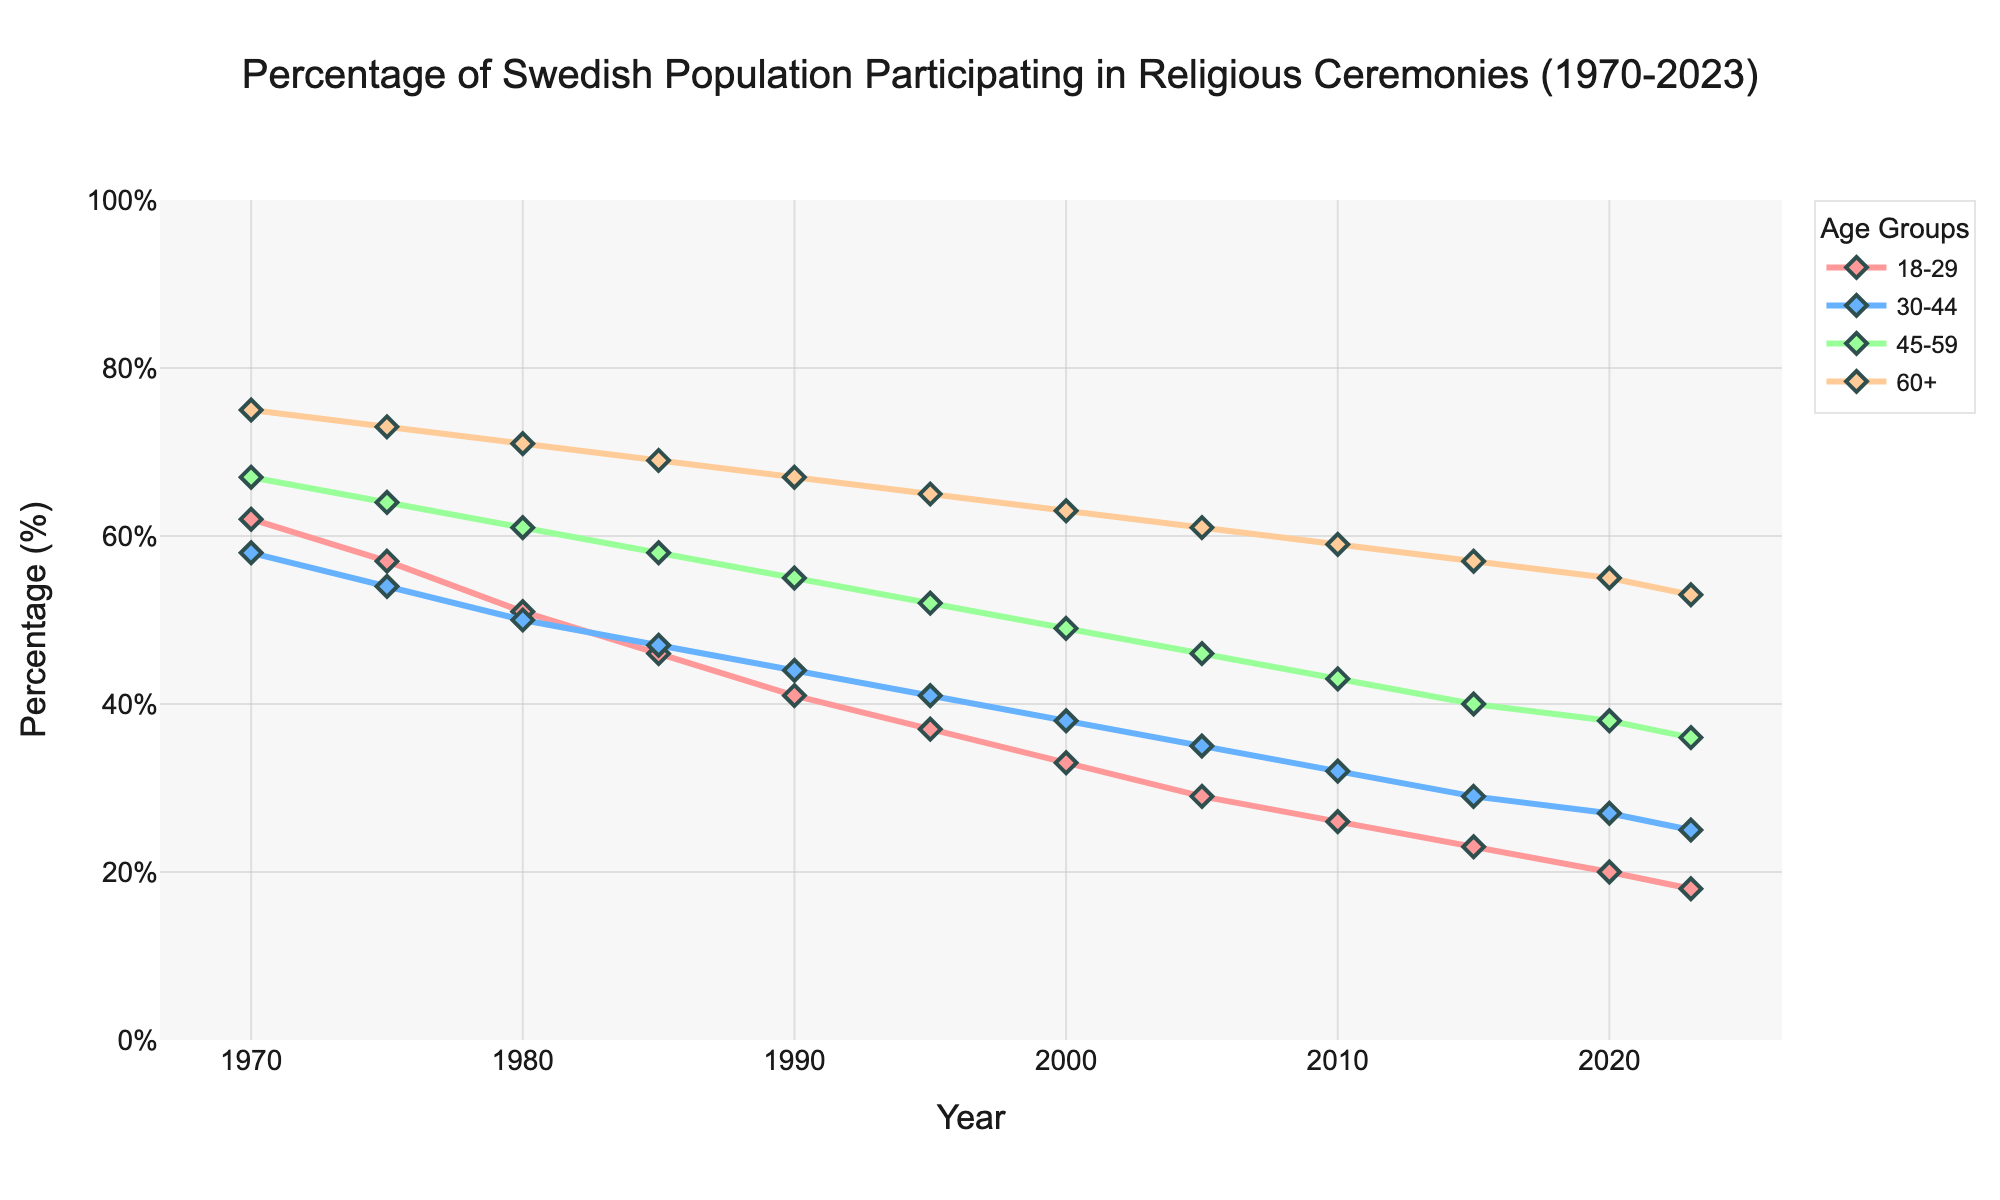What trend do you observe in the participation of the 18-29 age group over the years? The line for the 18-29 age group shows a consistent downward trend from 1970 (62%) to 2023 (18%). This indicates a decline in participation in religious ceremonies for this age group over time.
Answer: A consistent downward trend Which age group had the highest participation percentage in 1970? By looking at the lines in the chart, the 60+ age group had the highest participation percentage in 1970, with 75%.
Answer: 60+ age group In which year did the 45-59 age group first fall below 50% participation? By observing the chart, the 45-59 age group first falls below 50% in 1995, where they have a participation rate of 49%.
Answer: 1995 How does the participation rate of the 30-44 age group in 2023 compare to that of the 60+ age group in 1980? In 2023, the participation rate of the 30-44 age group is 25%, while in 1980, the 60+ age group had a participation rate of 71%. The participation rate for the 60+ age group in 1980 is significantly higher than that for the 30-44 age group in 2023.
Answer: 71% for 60+ in 1980 vs. 25% for 30-44 in 2023 Which age group shows the smallest decline in participation percentage from 1970 to 2023? By comparing the starting and ending points for each age group in the chart, the 60+ age group shows the smallest decline, from 75% in 1970 to 53% in 2023, a difference of 22 percentage points.
Answer: 60+ age group What is the average participation rate of the 18-29 age group from 2000 to 2023? The participation rates for the 18-29 age group from 2000 to 2023 are: 33%, 29%, 26%, 23%, 20%, 18%. Summing these, we get 149. Dividing by the number of data points (6), the average is 149 / 6 ≈ 24.83%.
Answer: 24.83% In which year did the 60+ age group drop below 60%? By examining the chart, the 60+ age group drops below 60% in 2010, with a participation rate of 59%.
Answer: 2010 Compare the decline in participation rates for the 18-29 age group and the 45-59 age group over the period from 1970 to 2023. Which group experienced a larger decline? The 18-29 age group declined from 62% in 1970 to 18% in 2023, a drop of 44 percentage points. The 45-59 age group declined from 67% in 1970 to 36% in 2023, a drop of 31 percentage points. Therefore, the 18-29 age group experienced a larger decline.
Answer: 18-29 age group 